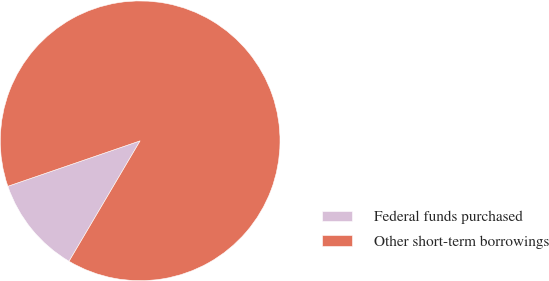Convert chart to OTSL. <chart><loc_0><loc_0><loc_500><loc_500><pie_chart><fcel>Federal funds purchased<fcel>Other short-term borrowings<nl><fcel>11.25%<fcel>88.75%<nl></chart> 